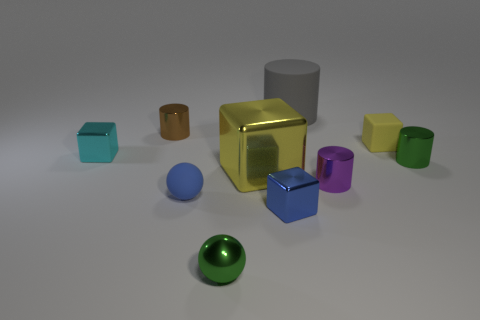Subtract 1 blocks. How many blocks are left? 3 Subtract all purple cubes. Subtract all red spheres. How many cubes are left? 4 Subtract all blocks. How many objects are left? 6 Subtract 0 yellow balls. How many objects are left? 10 Subtract all matte cubes. Subtract all small purple cylinders. How many objects are left? 8 Add 6 tiny yellow blocks. How many tiny yellow blocks are left? 7 Add 7 tiny brown metallic balls. How many tiny brown metallic balls exist? 7 